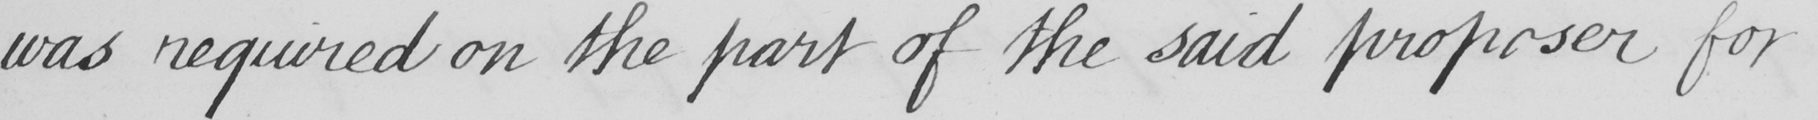Please transcribe the handwritten text in this image. was required on the part of the said proposer for 